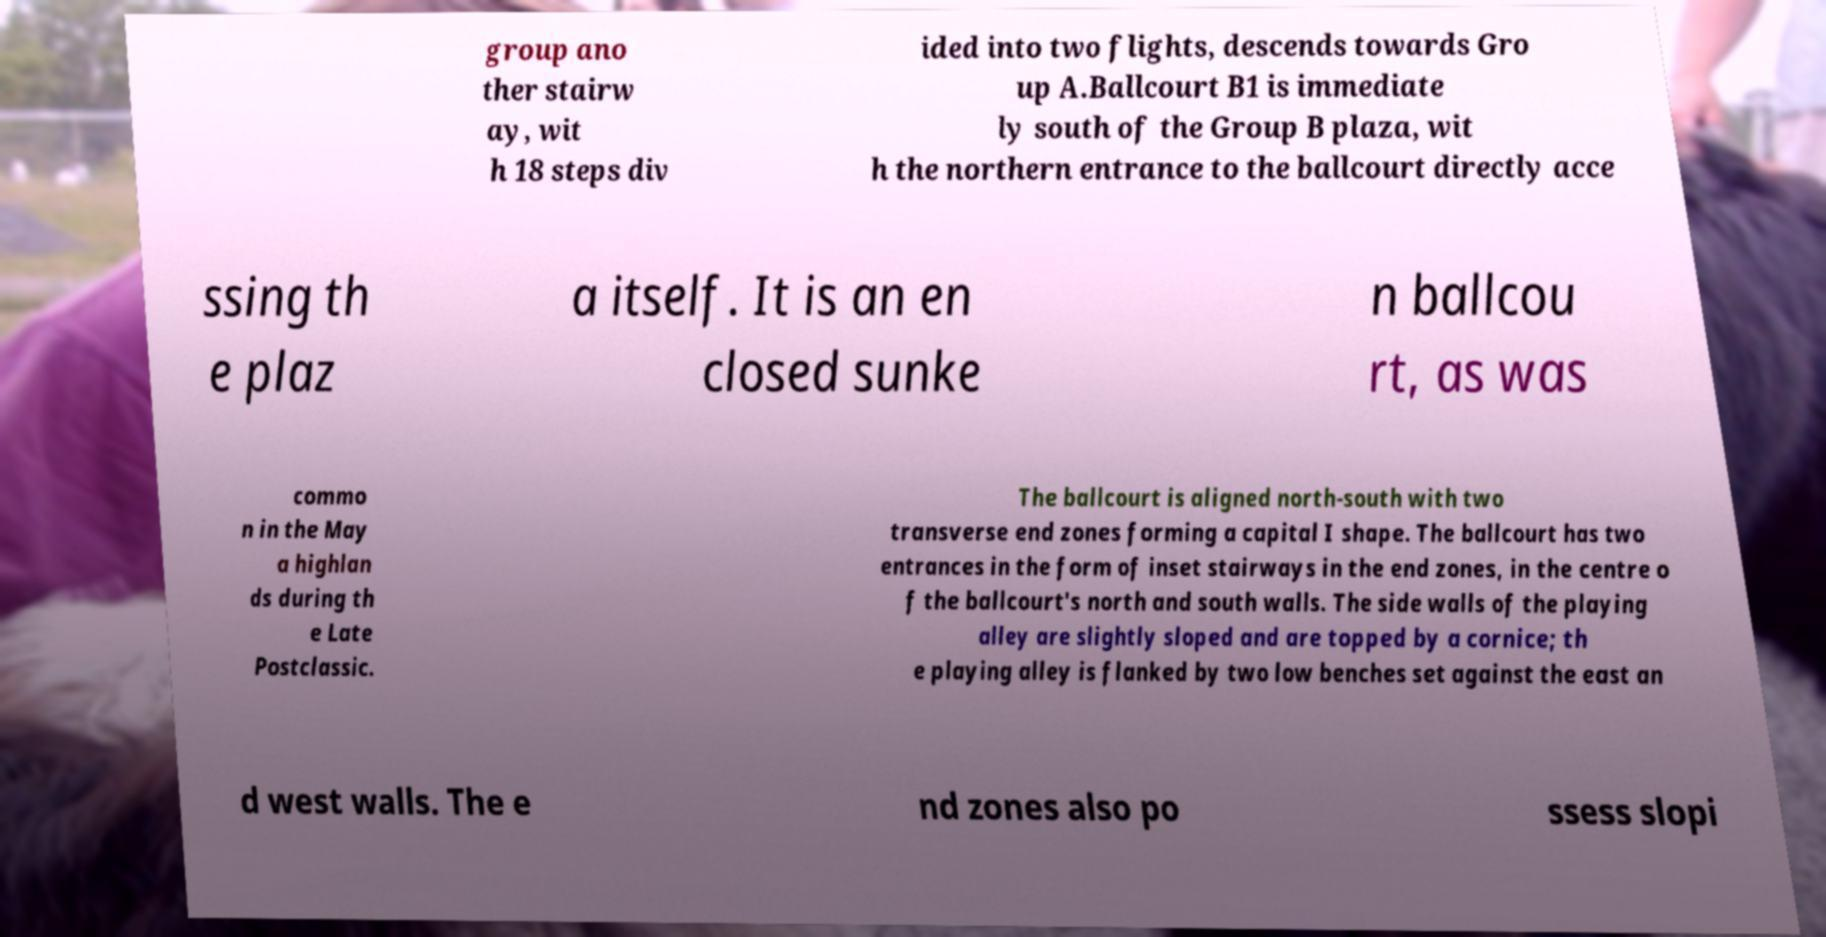Please read and relay the text visible in this image. What does it say? group ano ther stairw ay, wit h 18 steps div ided into two flights, descends towards Gro up A.Ballcourt B1 is immediate ly south of the Group B plaza, wit h the northern entrance to the ballcourt directly acce ssing th e plaz a itself. It is an en closed sunke n ballcou rt, as was commo n in the May a highlan ds during th e Late Postclassic. The ballcourt is aligned north-south with two transverse end zones forming a capital I shape. The ballcourt has two entrances in the form of inset stairways in the end zones, in the centre o f the ballcourt's north and south walls. The side walls of the playing alley are slightly sloped and are topped by a cornice; th e playing alley is flanked by two low benches set against the east an d west walls. The e nd zones also po ssess slopi 